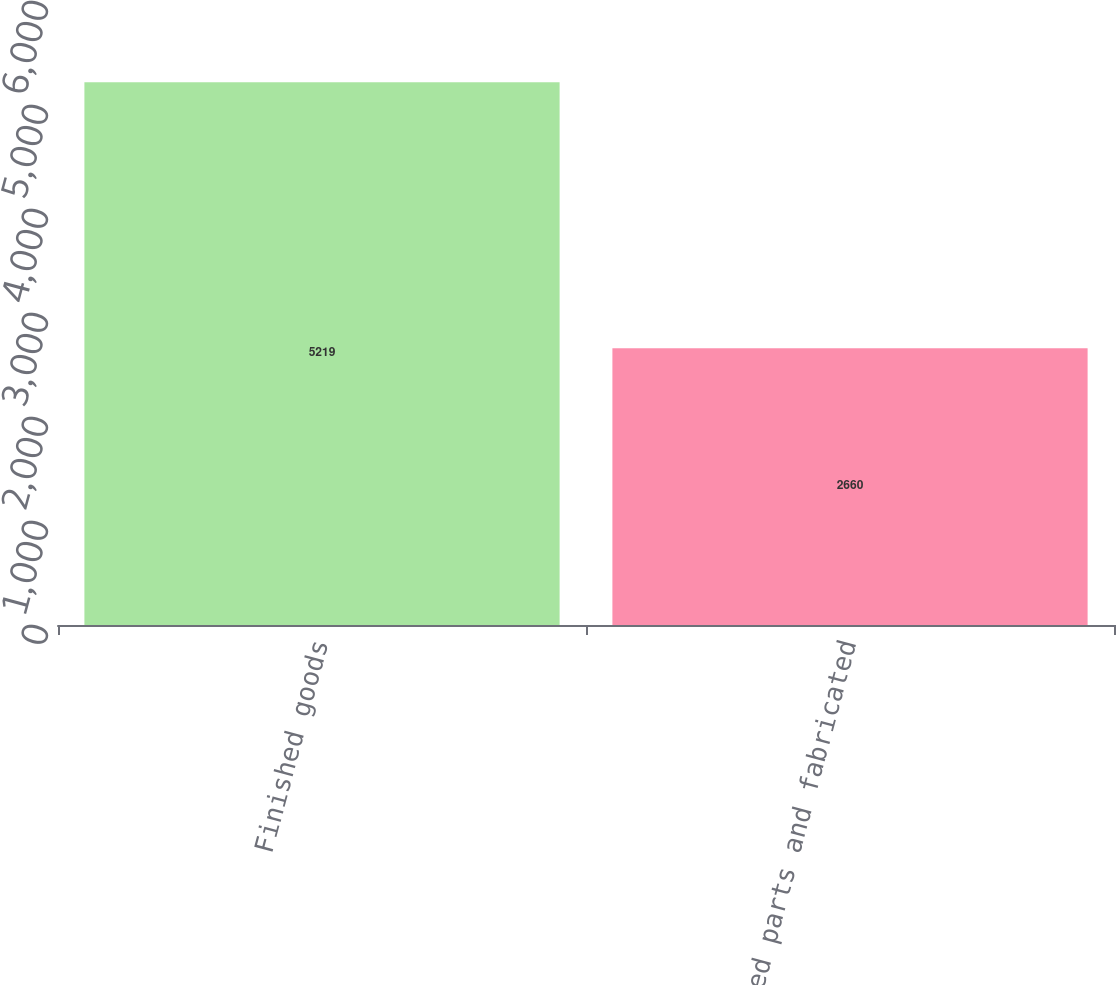<chart> <loc_0><loc_0><loc_500><loc_500><bar_chart><fcel>Finished goods<fcel>Purchased parts and fabricated<nl><fcel>5219<fcel>2660<nl></chart> 